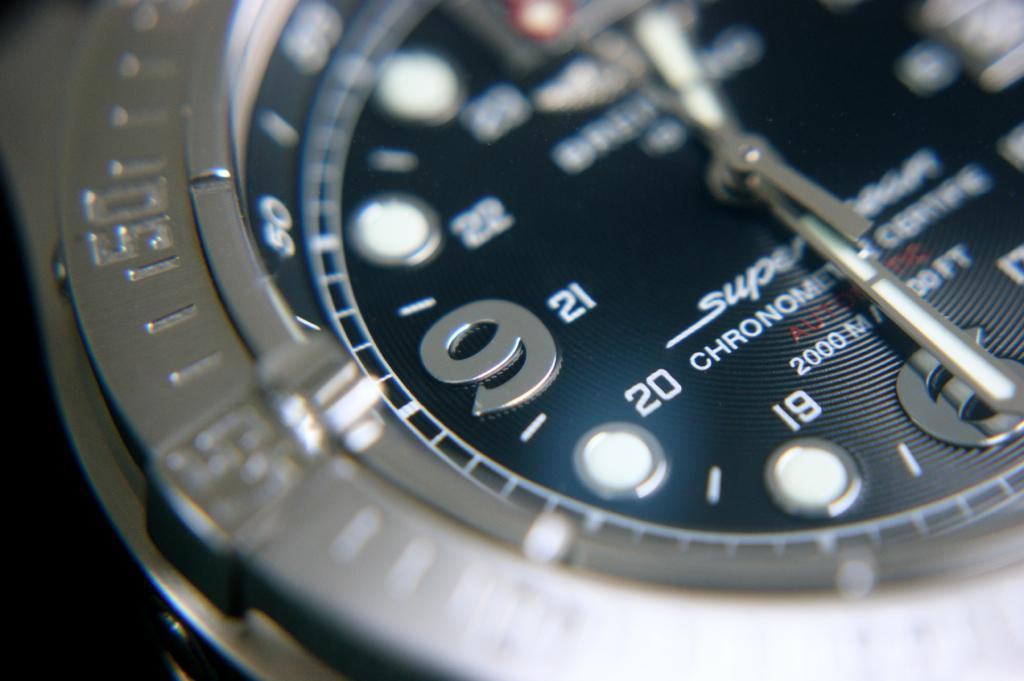What is the main subject of the image? The main subject of the image is a watch. What are the main components of the watch? The watch has hands, a dial, a case, and a bezel. Is there any text visible on the watch? Yes, there is text visible on the watch. Are there any numbers visible on the watch? Yes, there are numbers visible on the watch. What type of eggnog is being served by the grandmother in the image? There is no eggnog or grandmother present in the image; it features a watch with various components and details. 